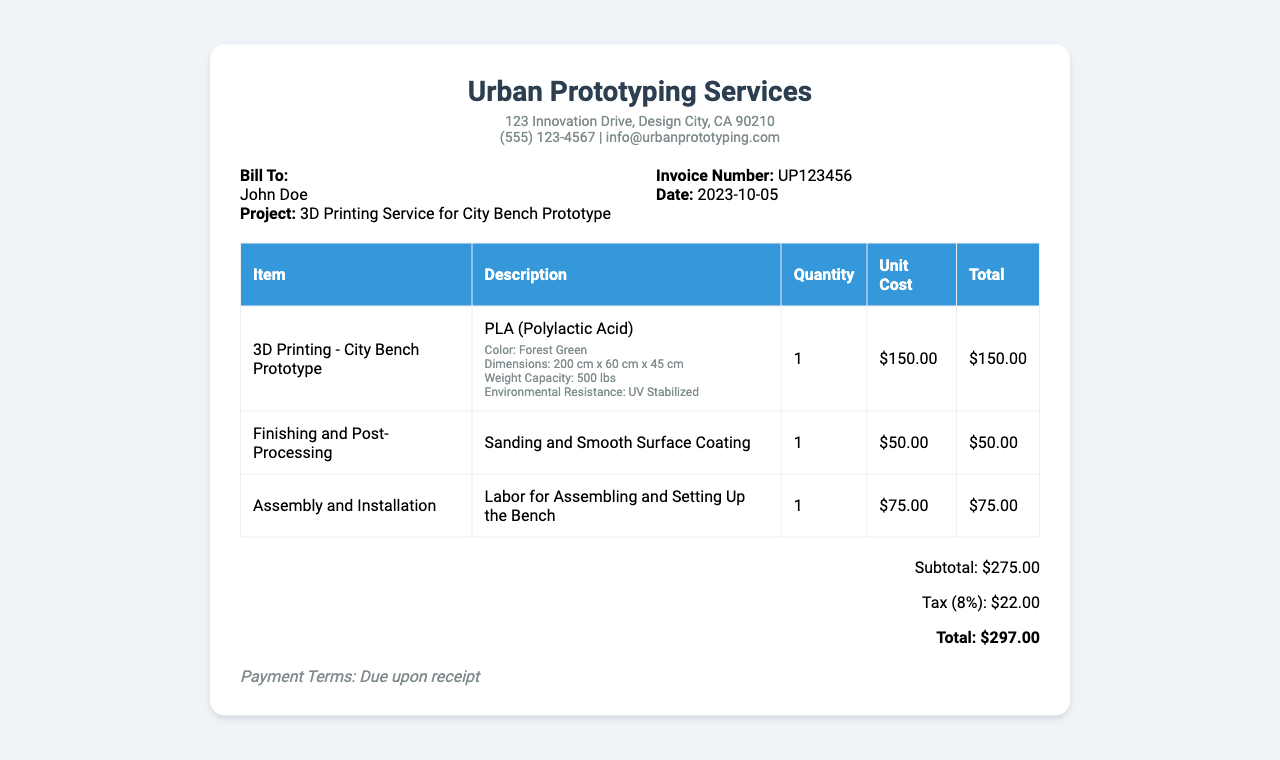What is the invoice number? The invoice number is provided in the document, under the invoice info section.
Answer: UP123456 What is the date of the invoice? The date is located in the invoice info section of the document.
Answer: 2023-10-05 What is the subtotal amount? The subtotal is listed in the total section of the document.
Answer: $275.00 What material is used for the city bench prototype? The material used is specified in the description of the 3D printing item.
Answer: PLA (Polylactic Acid) What is the color of the 3D printed city bench? The color is mentioned in the material specifications of the 3D printing item.
Answer: Forest Green How much is charged for finishing and post-processing? The cost is shown in the table under the unit cost for that service.
Answer: $50.00 What is the total amount including tax? The total is calculated by adding the subtotal and the tax, as shown in the total section.
Answer: $297.00 How many items are listed in the receipt? The total number of items can be counted from the rows in the items table of the receipt.
Answer: 3 What is the weight capacity of the city bench? The weight capacity is specified in the material specifications of the 3D printing item.
Answer: 500 lbs 